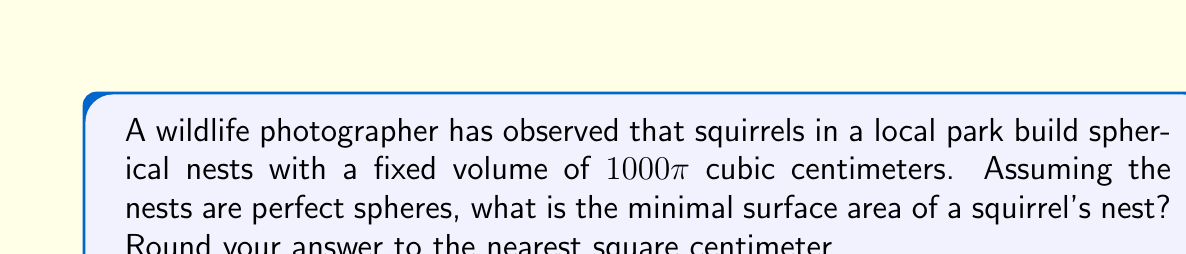Teach me how to tackle this problem. Let's approach this step-by-step:

1) For a sphere, the volume $V$ is given by:
   $$V = \frac{4}{3}\pi r^3$$
   where $r$ is the radius.

2) We're given that $V = 1000\pi$ cm³. Let's substitute this:
   $$1000\pi = \frac{4}{3}\pi r^3$$

3) Simplify:
   $$3000 = 4r^3$$
   $$750 = r^3$$

4) Solve for $r$:
   $$r = \sqrt[3]{750} \approx 9.0856\text{ cm}$$

5) Now, the surface area $A$ of a sphere is given by:
   $$A = 4\pi r^2$$

6) Substitute our value of $r$:
   $$A = 4\pi (9.0856)^2$$
   $$A \approx 1036.7\text{ cm}^2$$

7) Rounding to the nearest square centimeter:
   $$A \approx 1037\text{ cm}^2$$

This is the minimal surface area because a sphere always has the smallest surface area for a given volume.
Answer: 1037 cm² 